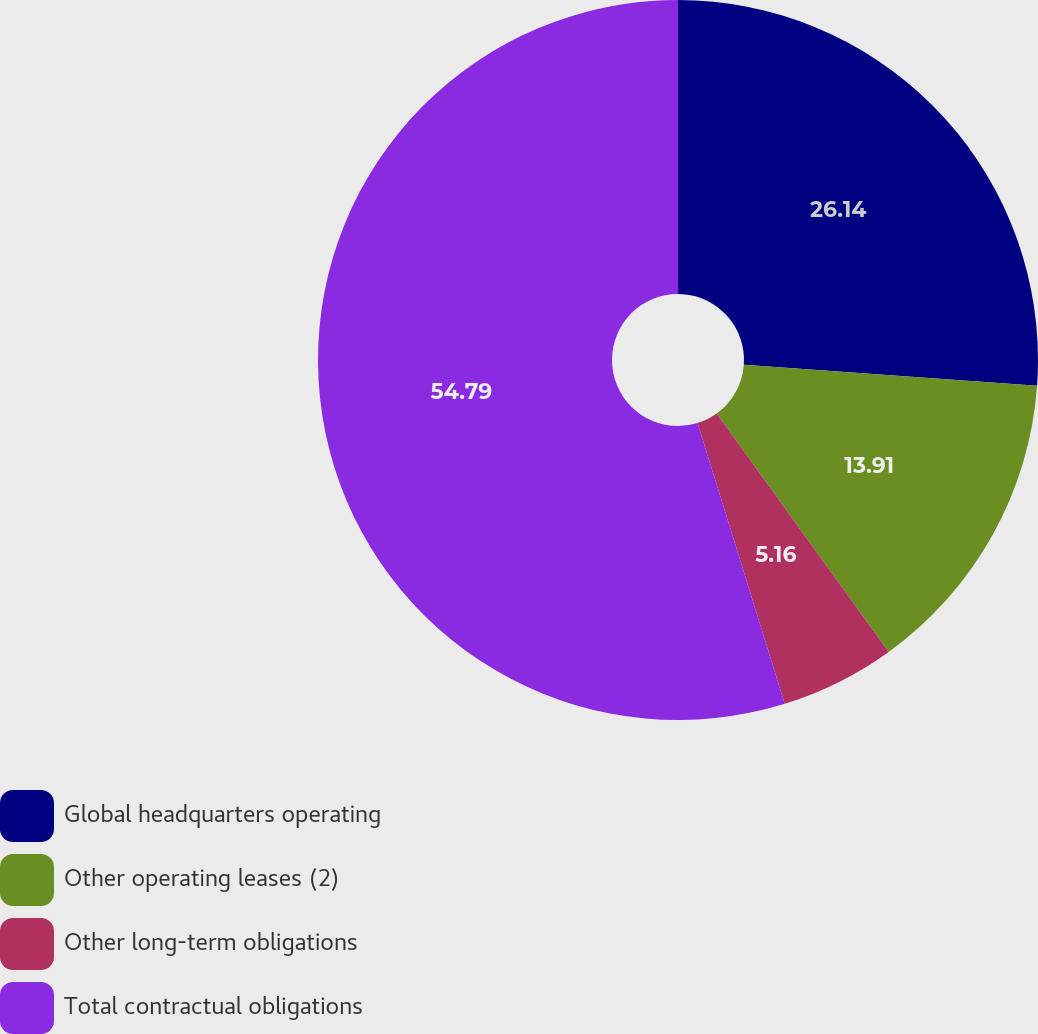<chart> <loc_0><loc_0><loc_500><loc_500><pie_chart><fcel>Global headquarters operating<fcel>Other operating leases (2)<fcel>Other long-term obligations<fcel>Total contractual obligations<nl><fcel>26.14%<fcel>13.91%<fcel>5.16%<fcel>54.79%<nl></chart> 